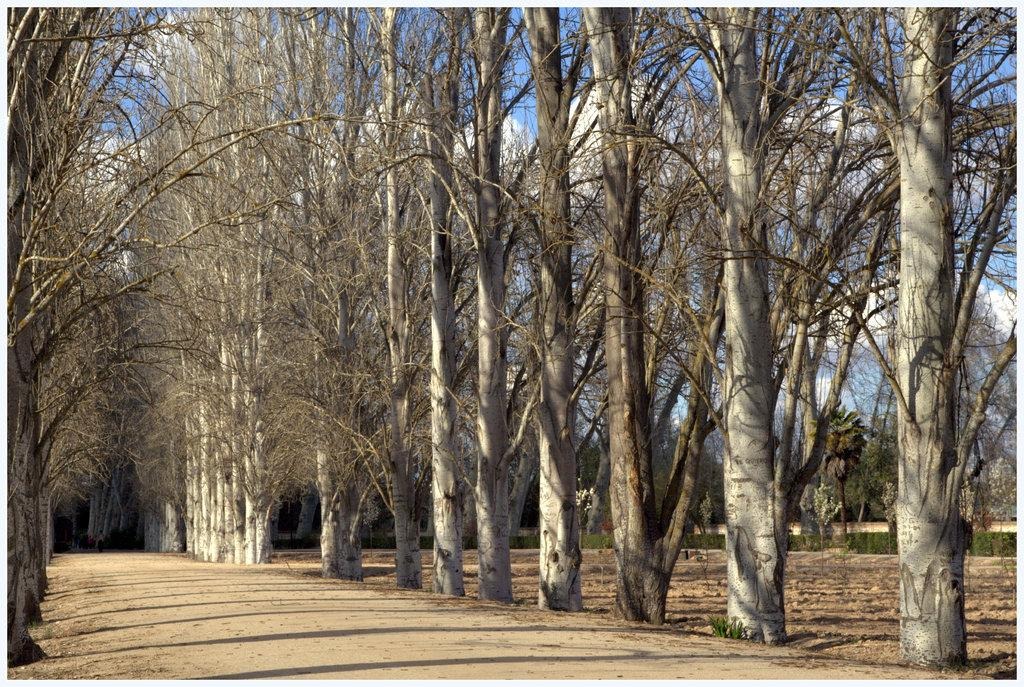What type of vegetation is present in the image? There is a group of trees and plants on the ground in the image. What can be seen in the background of the image? The sky is visible in the background of the image. What is the condition of the sky in the image? There are clouds in the sky in the image. Where is the desk located in the image? There is no desk present in the image. What type of transportation can be seen at the harbor in the image? There is no harbor or transportation present in the image. 